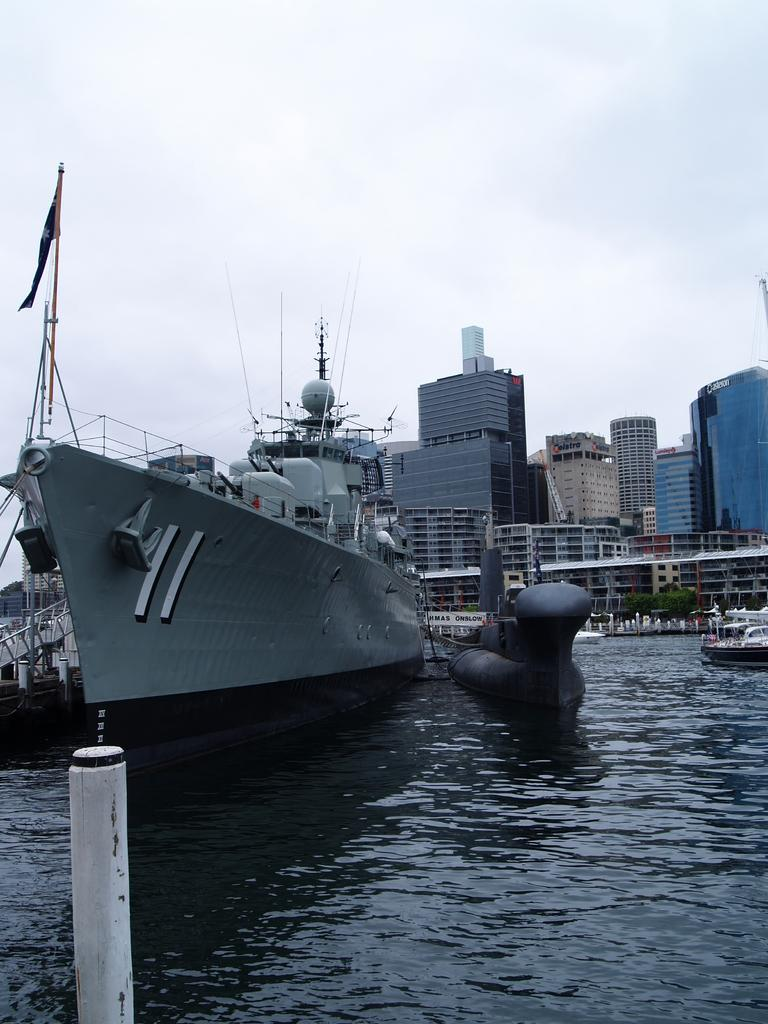What is the primary element in the image? There is water in the image. What is on the water in the image? There are ships on the water. What can be seen in the background of the image? There are buildings in the background of the image. What is visible at the top of the image? The sky is visible at the top of the image. Where are the flowers growing in the image? There are no flowers present in the image. What type of egg can be seen in the image? There is no egg present in the image. 